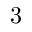<formula> <loc_0><loc_0><loc_500><loc_500>3</formula> 